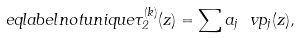Convert formula to latex. <formula><loc_0><loc_0><loc_500><loc_500>\ e q l a b e l { n o t u n i q u e } \tau _ { 2 } ^ { ( k ) } ( z ) = \sum a _ { j } \ v p _ { j } ( z ) ,</formula> 